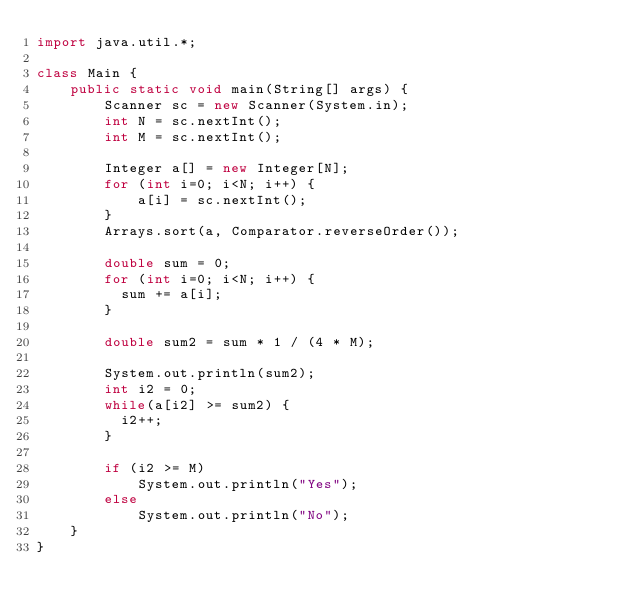Convert code to text. <code><loc_0><loc_0><loc_500><loc_500><_Java_>import java.util.*;

class Main {
    public static void main(String[] args) {
        Scanner sc = new Scanner(System.in);
        int N = sc.nextInt();
        int M = sc.nextInt();
      
      	Integer a[] = new Integer[N];
      	for (int i=0; i<N; i++) {
            a[i] = sc.nextInt();
        }
        Arrays.sort(a, Comparator.reverseOrder());
      
      	double sum = 0;
        for (int i=0; i<N; i++) {
          sum += a[i];
        }
      
      	double sum2 = sum * 1 / (4 * M);

      	System.out.println(sum2);
      	int i2 = 0;
      	while(a[i2] >= sum2) {
          i2++;
        }
      	
      	if (i2 >= M)
            System.out.println("Yes");
        else
            System.out.println("No");
    }
}</code> 